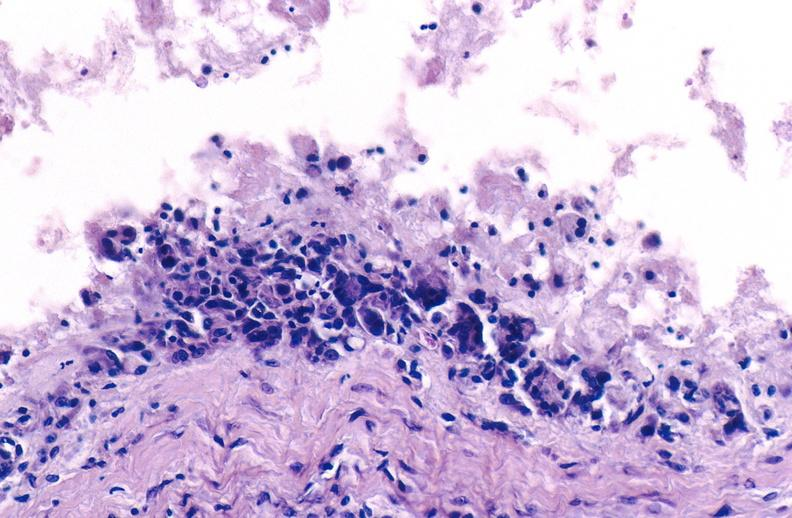does this image show gout?
Answer the question using a single word or phrase. Yes 